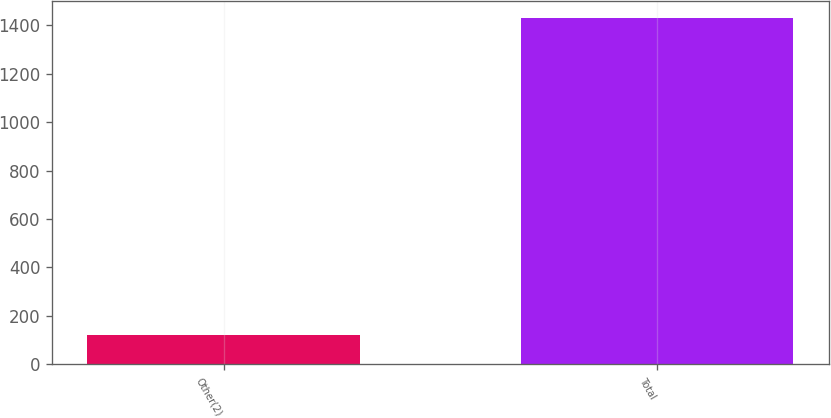<chart> <loc_0><loc_0><loc_500><loc_500><bar_chart><fcel>Other(2)<fcel>Total<nl><fcel>120<fcel>1428<nl></chart> 